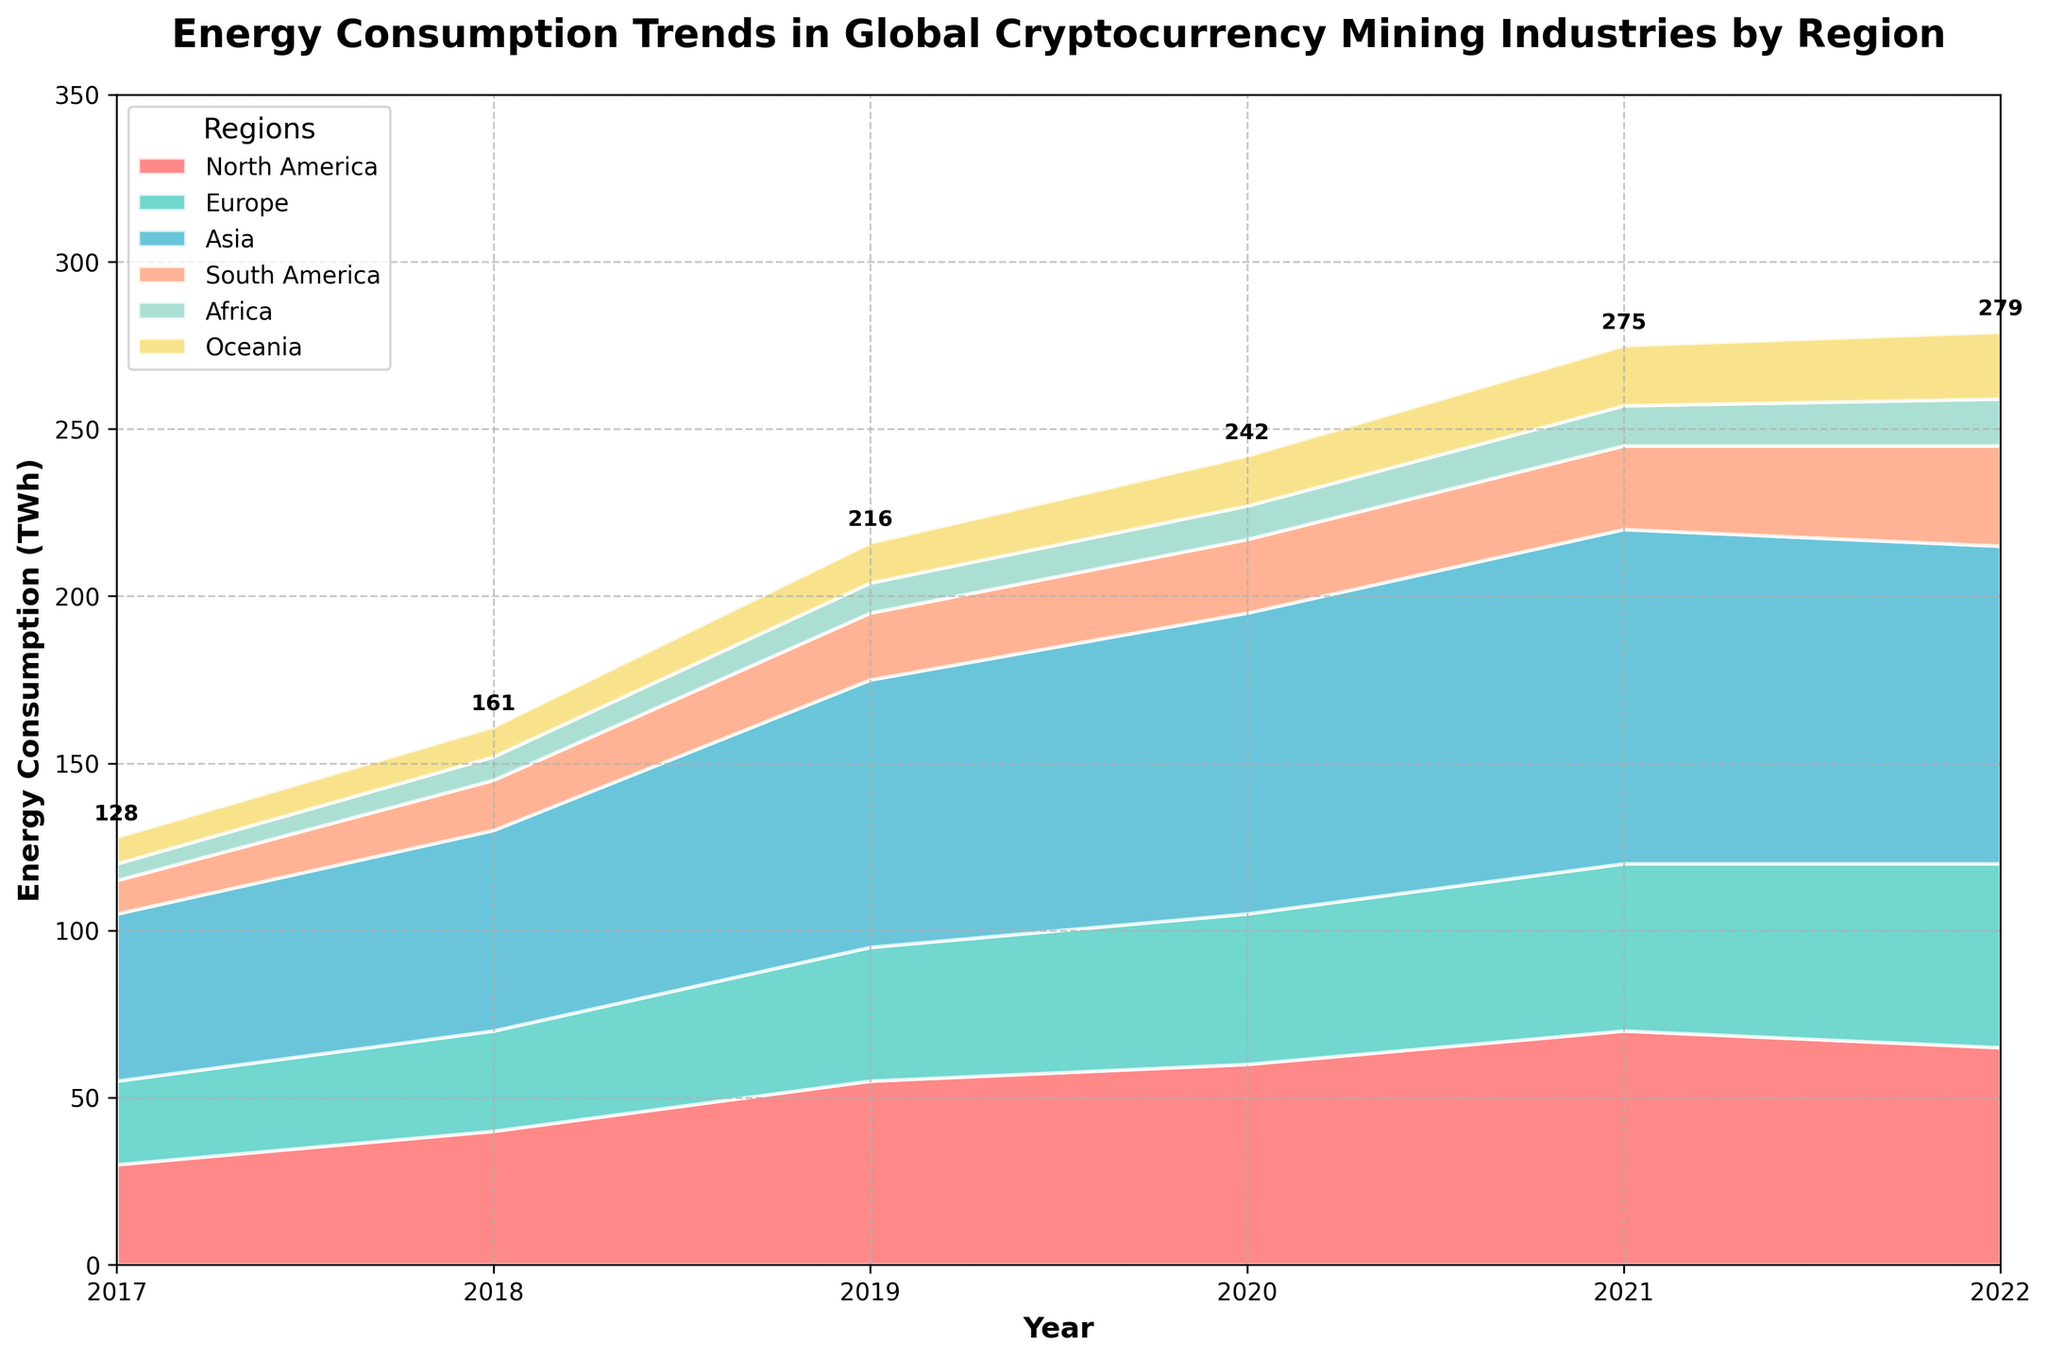What is the title of the plot? Look at the top of the plot where the title is placed. It reads: "Energy Consumption Trends in Global Cryptocurrency Mining Industries by Region".
Answer: Energy Consumption Trends in Global Cryptocurrency Mining Industries by Region How many regions are represented in the plot? By observing the legend or the labels used in the plot, six regions are represented (North America, Europe, Asia, South America, Africa, and Oceania).
Answer: 6 Which region had the highest energy consumption in 2020? Look at the relative area sizes for the year 2020 in the plot. Asia has the largest area which indicates the highest energy consumption.
Answer: Asia What is the overall trend in energy consumption for Europe from 2017 to 2022? Observe the area corresponding to Europe from 2017 to 2022. The energy consumption for Europe shows a steady increase over the years.
Answer: Increasing What was the total energy consumption across all regions in 2021? Add up the individual consumption values for each region in 2021 mentioned in the annotations on the plot. For 2021, the values are approximately 70 + 50 + 100 + 25 + 12 + 18 = 275 TWh.
Answer: 275 TWh By how much did the energy consumption in North America change from 2019 to 2022? Look at the area size for North America in 2019 and 2022 and note their energy consumption values: 55 TWh in 2019 and 65 TWh in 2022. The difference is 65 - 55 = 10 TWh.
Answer: 10 TWh Which year recorded the highest total energy consumption across all regions? Check the total height (cumulative area) for each year by looking at the annotations. 2021 appears to have the highest annotation value (275 TWh).
Answer: 2021 What region saw the smallest increase in energy consumption from 2017 to 2022? Compare the relative changes in area for each region from 2017 to 2022. Africa's energy consumption increased from 5 TWh to 14 TWh, which is the smallest increase.
Answer: Africa In 2018, which region had the second-highest energy consumption? Look at the stacked areas for 2018 and their relative sizes. North America had the second-highest area after Asia.
Answer: North America How did Oceania's energy consumption trend compare with South America's from 2017 to 2022? Compare the trend of the stacked areas for Oceania and South America. Both regions show a gradual increase, but South America's increase is slightly steeper.
Answer: Similar, but South America increased more 